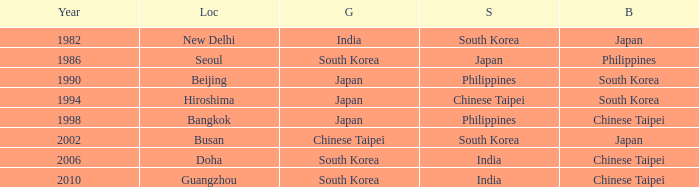Which Location has a Silver of japan? Seoul. 